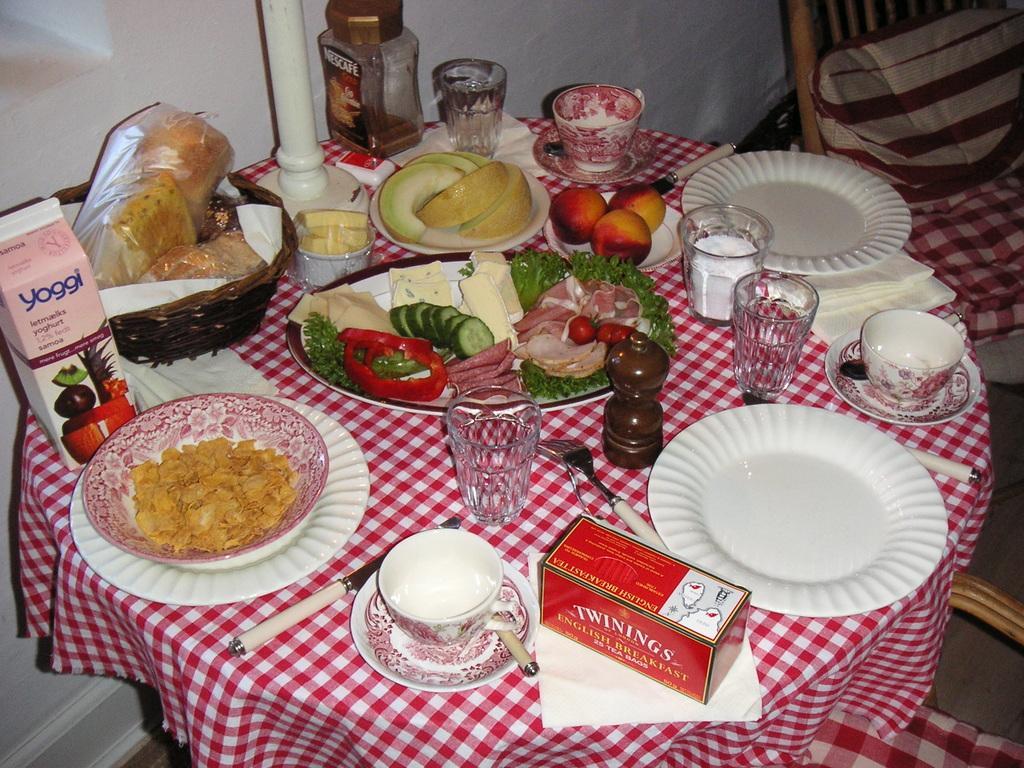Could you give a brief overview of what you see in this image? The picture consists of a table covered with cloth, on the table there are plates, platter, glasses, cups, saucer, tissues, jar, basket, food items, forks, spoon and other objects. On the right there are chairs. At the top there is a wall painted white. 